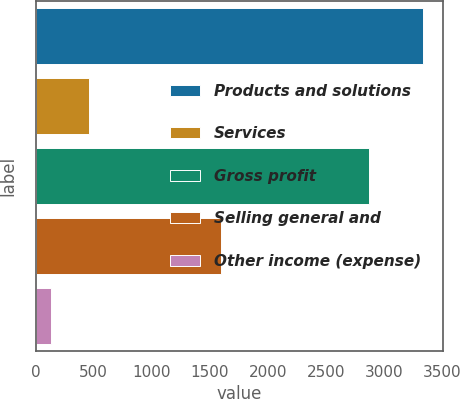Convert chart. <chart><loc_0><loc_0><loc_500><loc_500><bar_chart><fcel>Products and solutions<fcel>Services<fcel>Gross profit<fcel>Selling general and<fcel>Other income (expense)<nl><fcel>3338.6<fcel>455.2<fcel>2872.2<fcel>1599<fcel>130.6<nl></chart> 